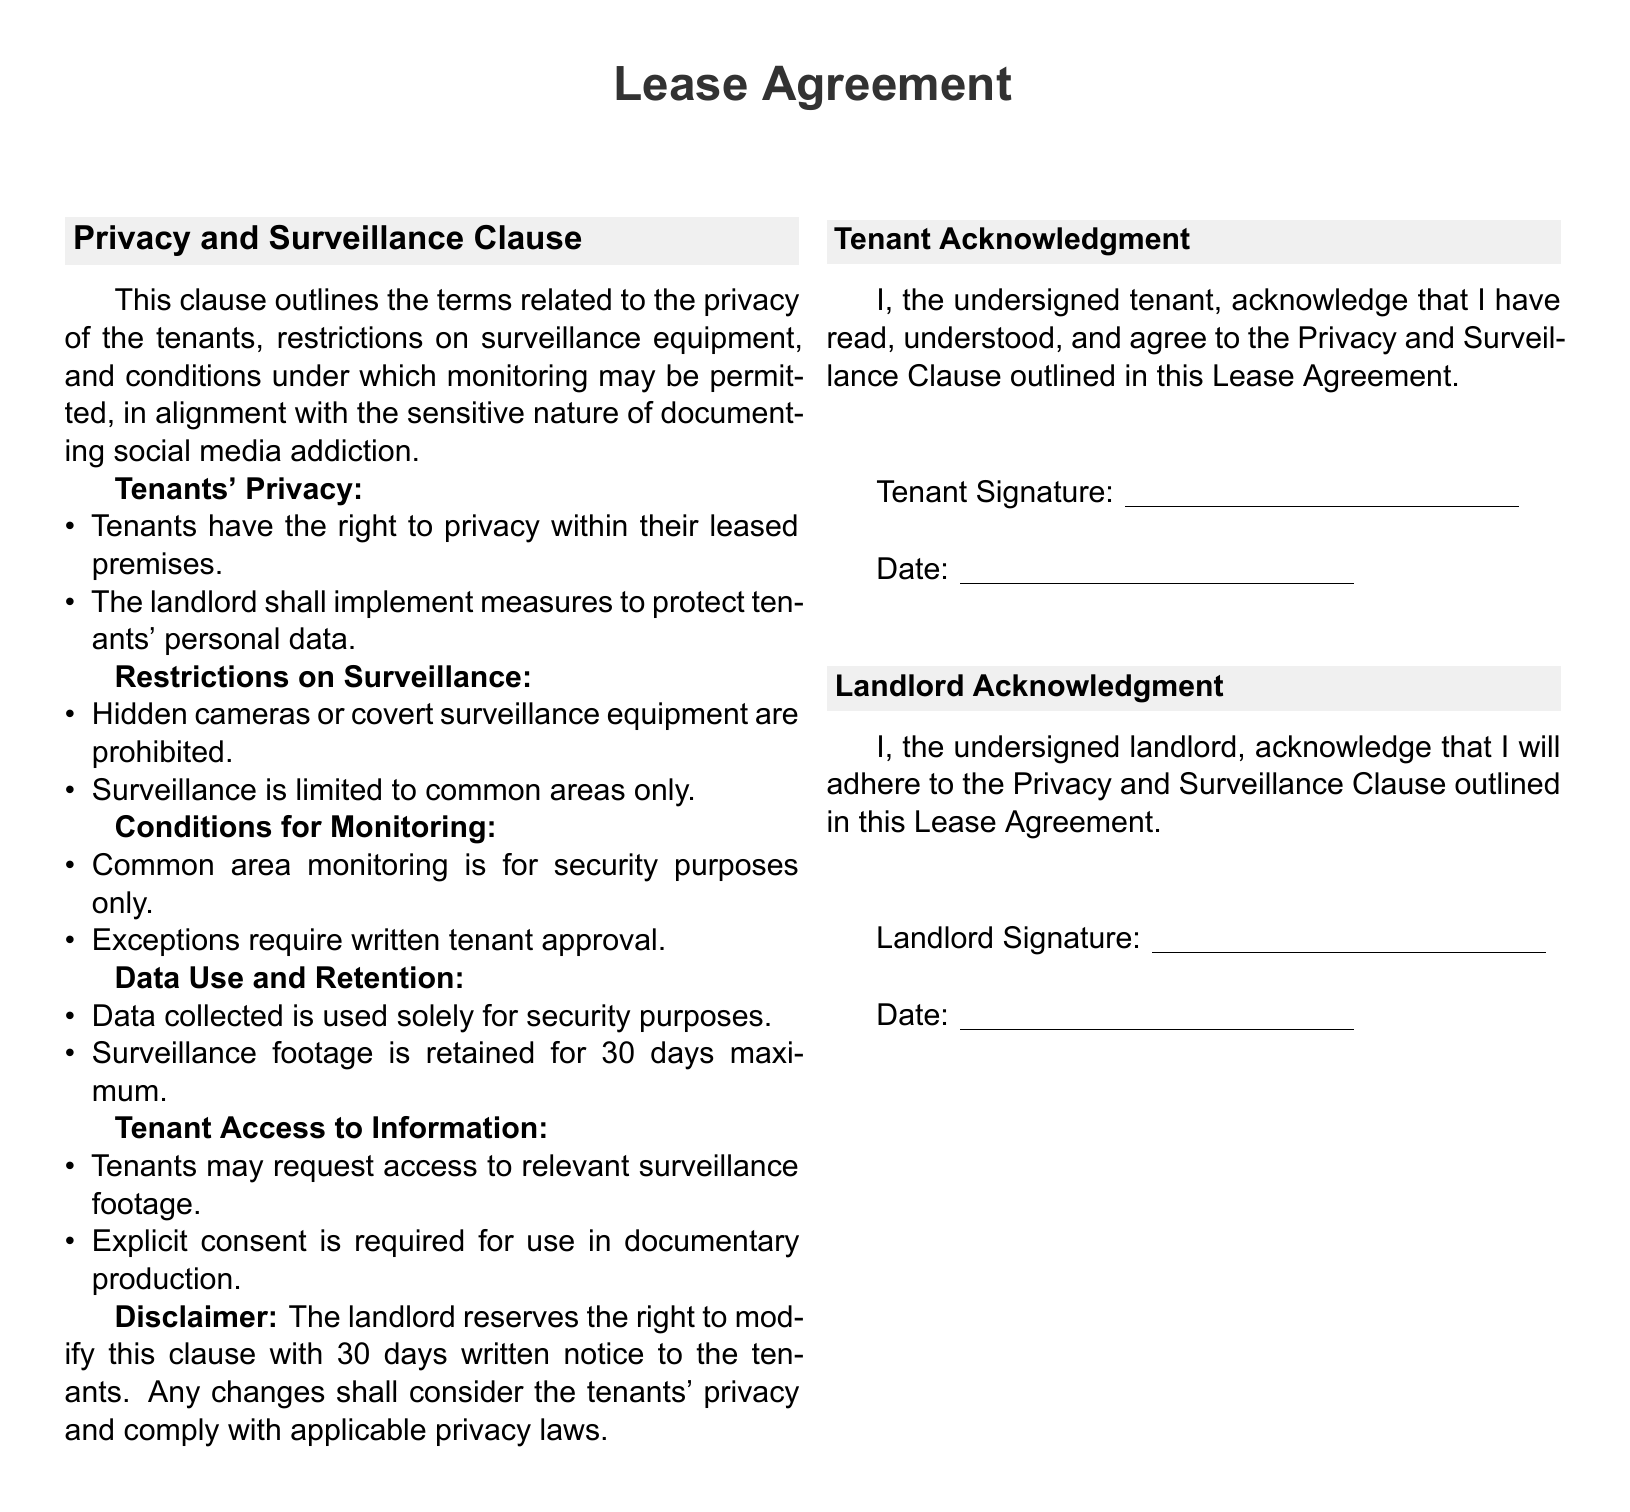What is the title of the clause? The title of the clause is the section heading in the document, specifically detailing privacy and surveillance arrangements.
Answer: Privacy and Surveillance Clause What rights do tenants have regarding their leased premises? This pertains to the privileges granted to tenants concerning their living space as detailed in the document.
Answer: Right to privacy Are hidden cameras allowed according to the clause? This question addresses the permissible surveillance equipment outlined in the document.
Answer: Prohibited How long is surveillance footage retained? This question inquires about the duration for which surveillance data is stored as specified in the document.
Answer: 30 days What must happen for monitoring to take place in common areas? This question looks at the conditions required for monitoring noted in the clause regarding its justification.
Answer: Security purposes only Who must provide explicit consent for footage use in documentary production? This question identifies the individual whose permission is necessary for specific uses of collected data as mentioned in the document.
Answer: Tenants What type of data is collected according to the clause? This question addresses the focus of the data collection efforts as outlined in the document.
Answer: Security purposes What is required for exceptions to surveillance monitoring? This question examines what must be obtained for deviations from standard monitoring conditions as indicated in the lease agreement.
Answer: Written tenant approval How will changes to the clause be communicated to tenants? This question refers to the method stipulated in the document on how updates to the clause will be conveyed.
Answer: 30 days written notice 